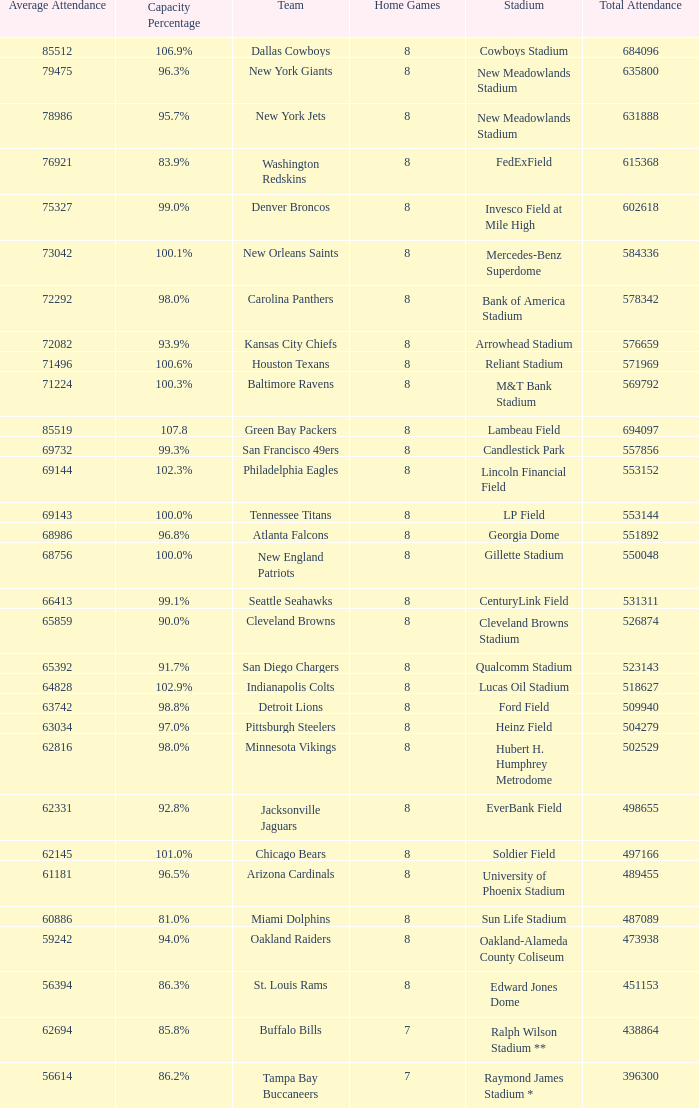How many home games are listed when the average attendance is 79475? 1.0. 